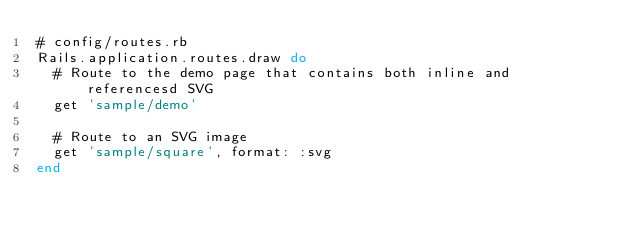<code> <loc_0><loc_0><loc_500><loc_500><_Ruby_># config/routes.rb
Rails.application.routes.draw do
  # Route to the demo page that contains both inline and referencesd SVG
  get 'sample/demo'

  # Route to an SVG image
  get 'sample/square', format: :svg
end
</code> 